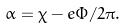Convert formula to latex. <formula><loc_0><loc_0><loc_500><loc_500>\alpha = \chi - e \Phi / 2 \pi .</formula> 